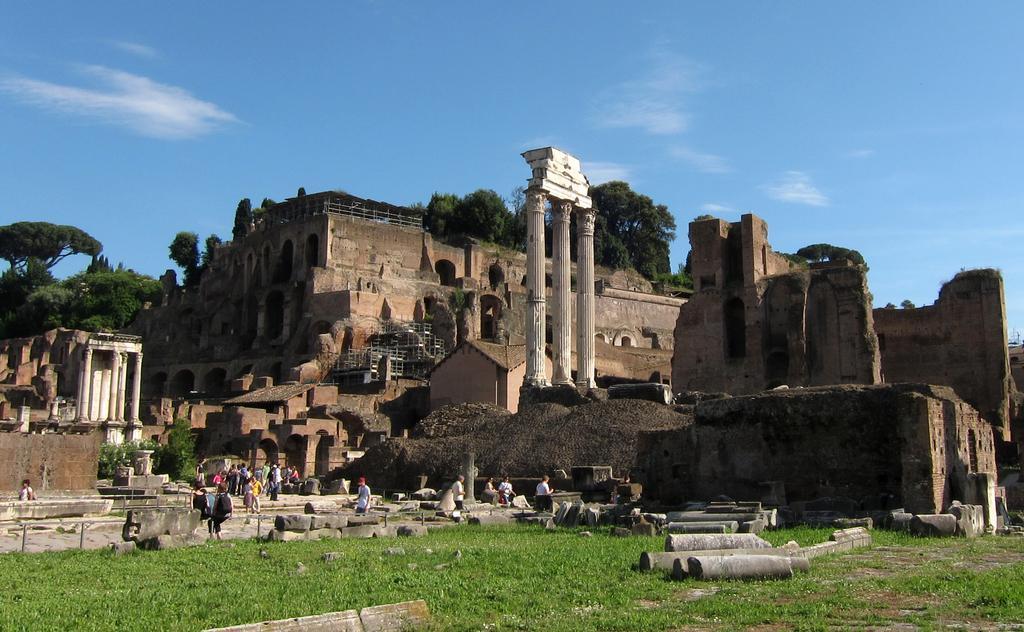How would you summarize this image in a sentence or two? In this image there is a monument in middle of this image and there are some trees behind it and there is a sky at top of this image and there are some persons standing at bottom of this image and there is some grass at bottom of this image. 